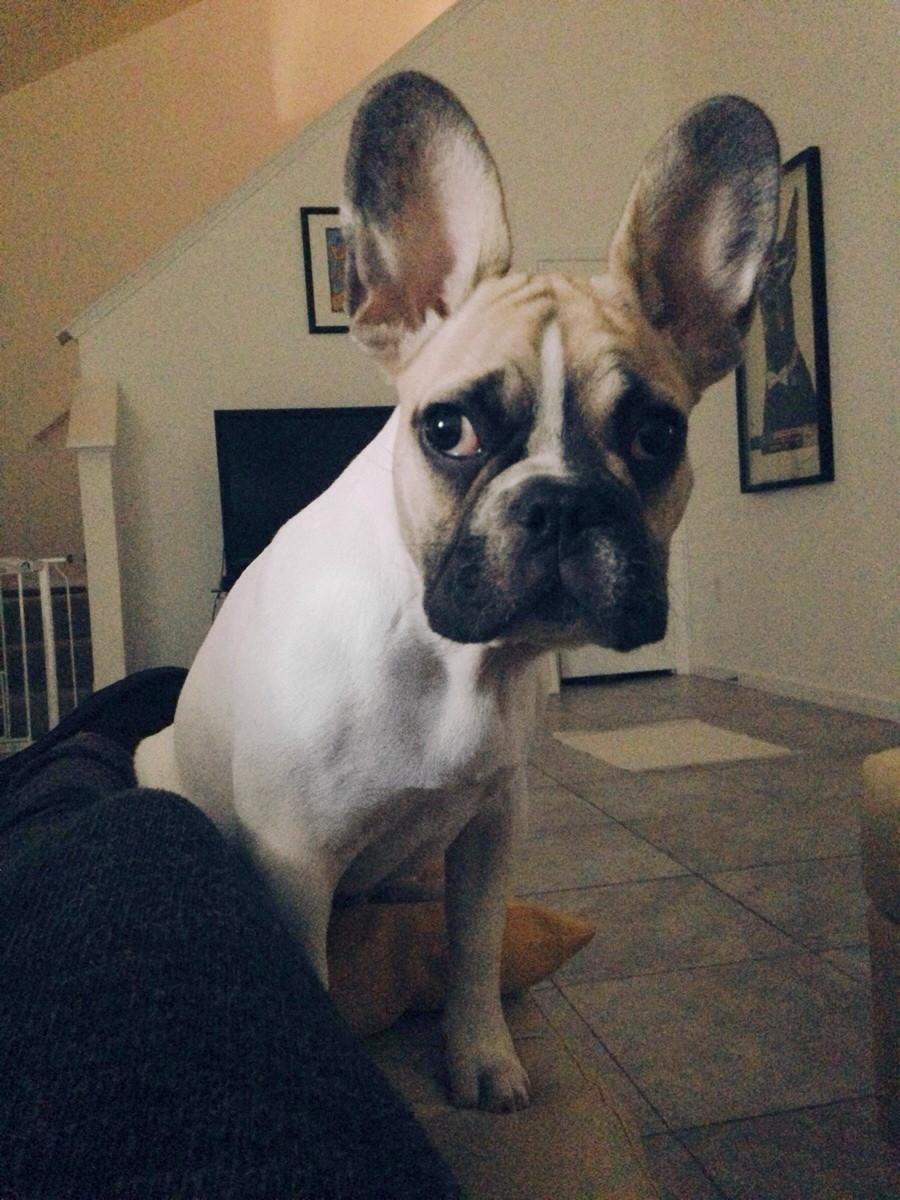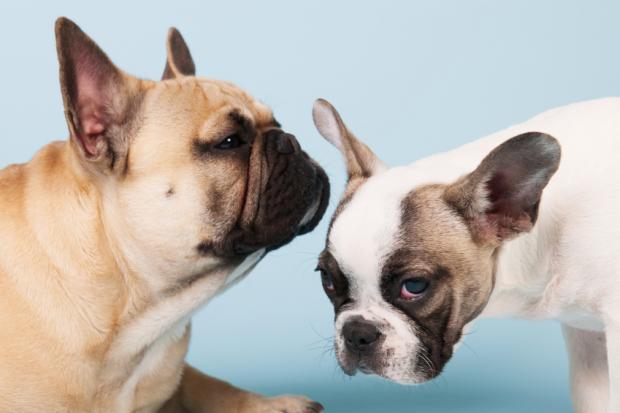The first image is the image on the left, the second image is the image on the right. Examine the images to the left and right. Is the description "The dog in the left image has tape on its ears." accurate? Answer yes or no. No. The first image is the image on the left, the second image is the image on the right. Considering the images on both sides, is "At least one image shows a dark-furred dog with masking tape around at least one ear." valid? Answer yes or no. No. 